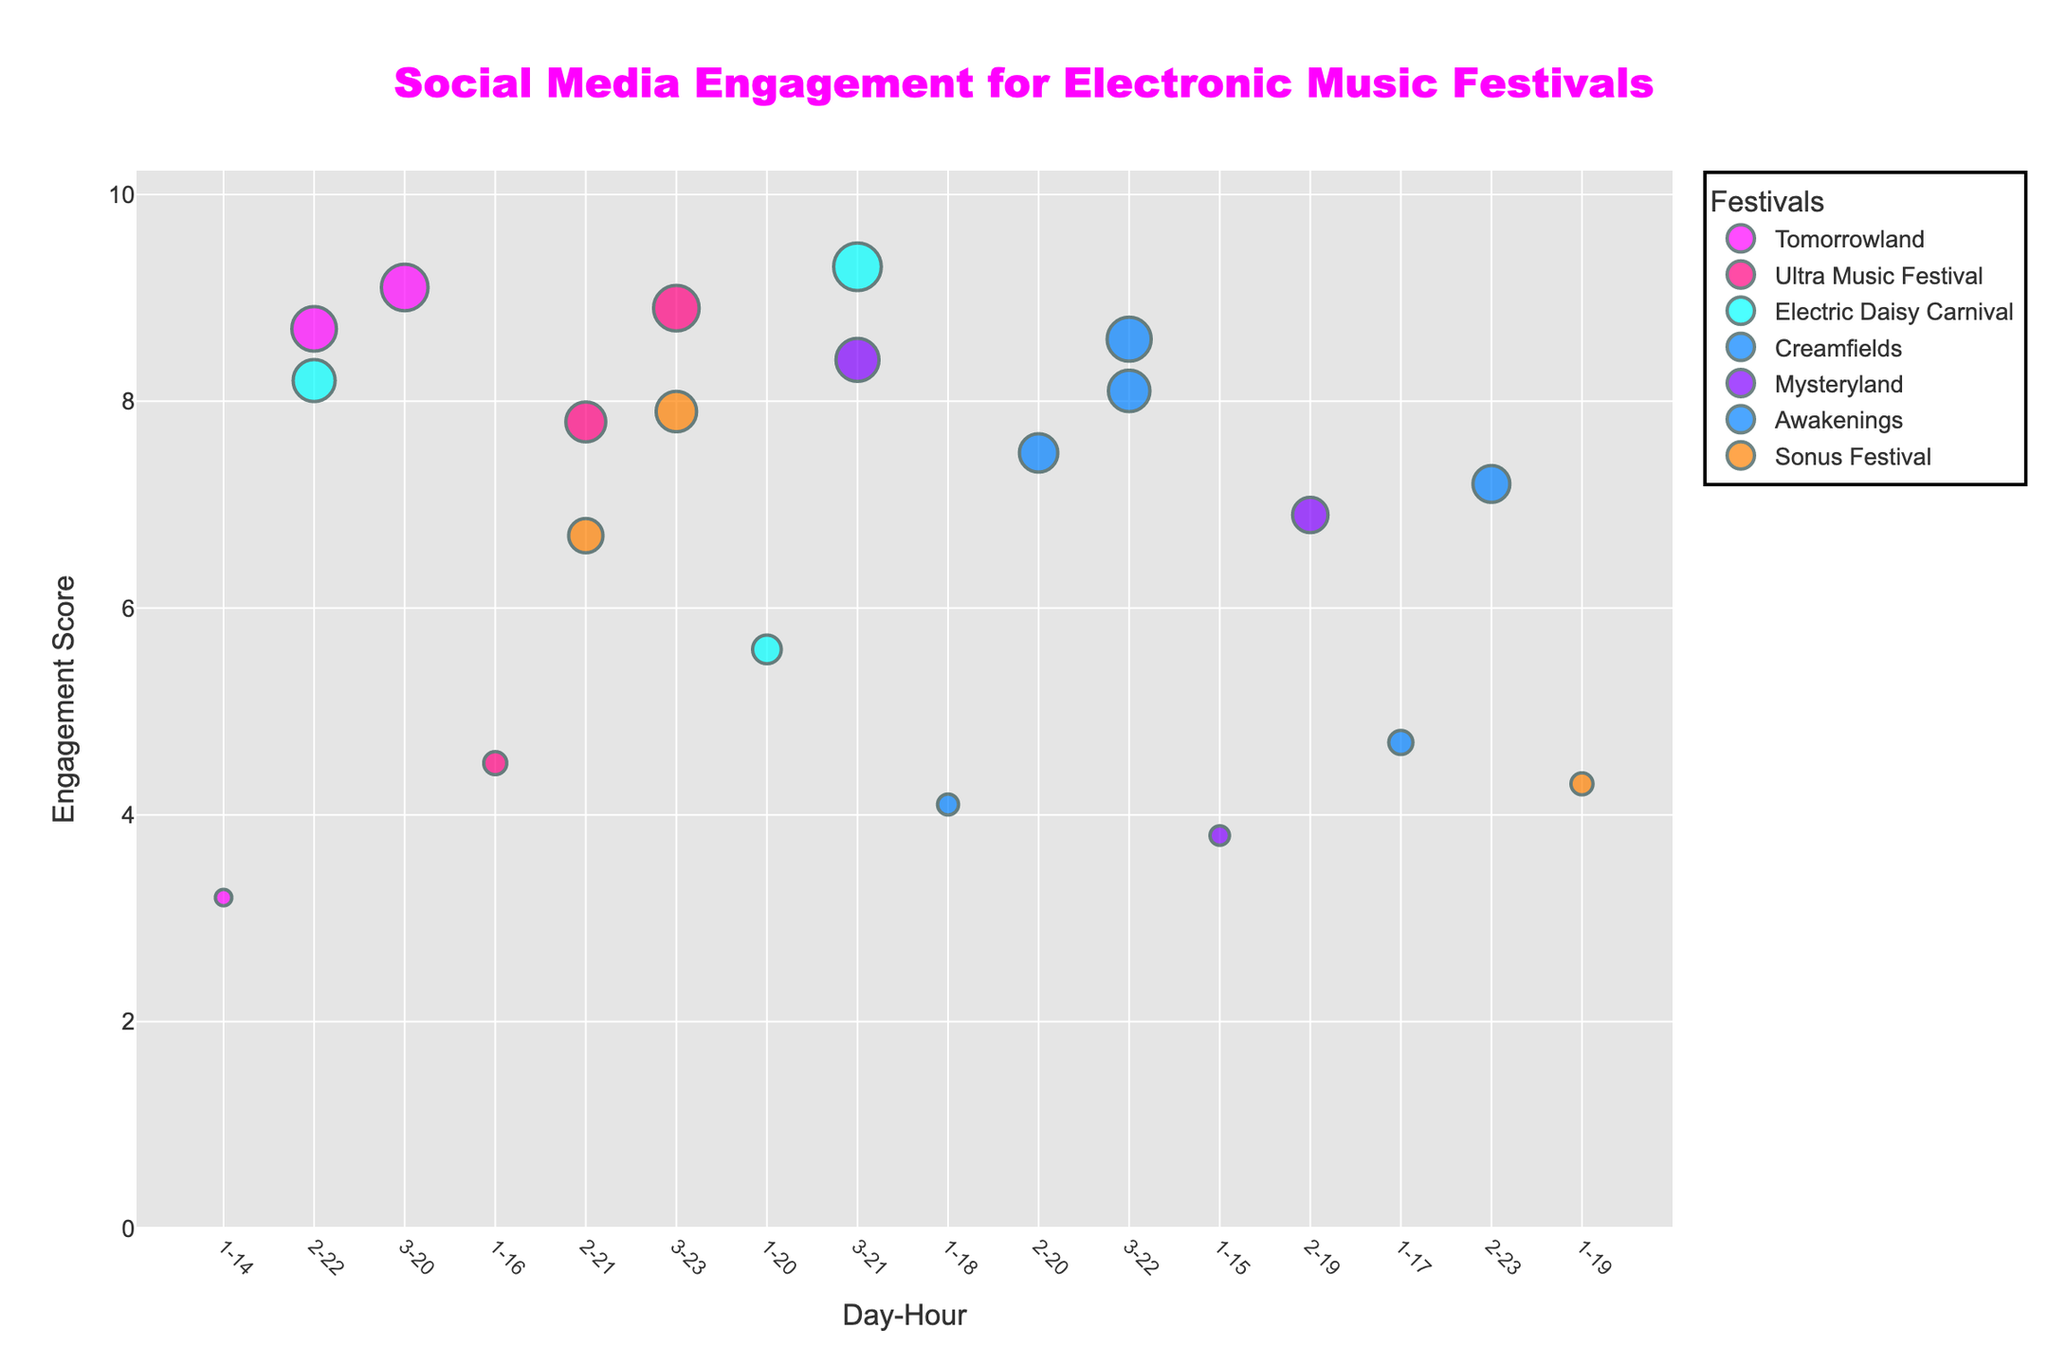What is the title of the plot? The title is prominently displayed at the top of the plot.
Answer: Social Media Engagement for Electronic Music Festivals Which festival has the highest engagement score? By examining the plot, we can identify the festival with the highest marker on the y-axis.
Answer: Electric Daisy Carnival On which day and hour does Tomorrowland reach its highest engagement score? Look at the markers for Tomorrowland and find the peak on the y-axis, then check the corresponding x-axis value.
Answer: Day 3, Hour 20 Compare the engagement scores of Creamfields on Day 2 and Day 3. Which day has higher engagement and by how much? Find the markers for Creamfields on Day 2 and Day 3, and compare their y-axis values. Subtract the smaller value from the larger one.
Answer: Day 3 by 1.1 During which hour does Ultra Music Festival see the most engagement on Day 3? Focus on Day 3 for Ultra Music Festival and identify the hour with the highest marker.
Answer: Hour 23 What is the range of engagement scores across all festivals? Identify the lowest and highest engagement scores from the y-axis markers and find the difference.
Answer: 3.2 to 9.3 Which festival shows the smallest difference in engagement scores between Day 1 and Day 3? Calculate the engagement score differences for Day 1 and Day 3 for each festival and find the smallest difference.
Answer: Awakenings Which festival has the most consistent engagement scores (smallest range) over the three days? Identify the range (difference between the highest and lowest scores) for each festival and determine which is smallest.
Answer: Mysteryland How does the engagement score of Sonus Festival on Day 2 compare to Tomorrowland on Day 2? Compare the y-axis markers for Sonus Festival on Day 2 with Tomorrowland on Day 2.
Answer: Tomorrowland is higher What is the average engagement score for Mysteryland across the three days? Sum the engagement scores for Mysteryland for all three days and divide by 3.
Answer: 6.37 